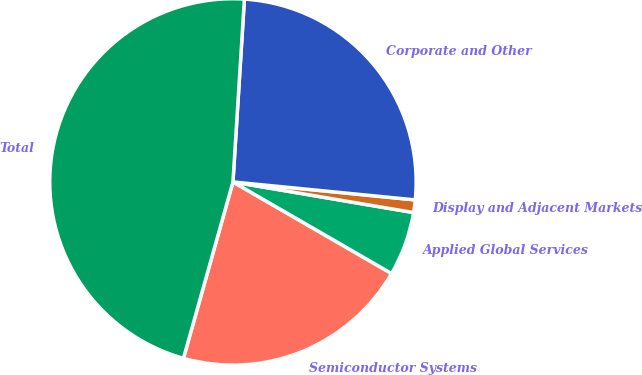Convert chart. <chart><loc_0><loc_0><loc_500><loc_500><pie_chart><fcel>Semiconductor Systems<fcel>Applied Global Services<fcel>Display and Adjacent Markets<fcel>Corporate and Other<fcel>Total<nl><fcel>21.02%<fcel>5.66%<fcel>1.11%<fcel>25.57%<fcel>46.64%<nl></chart> 